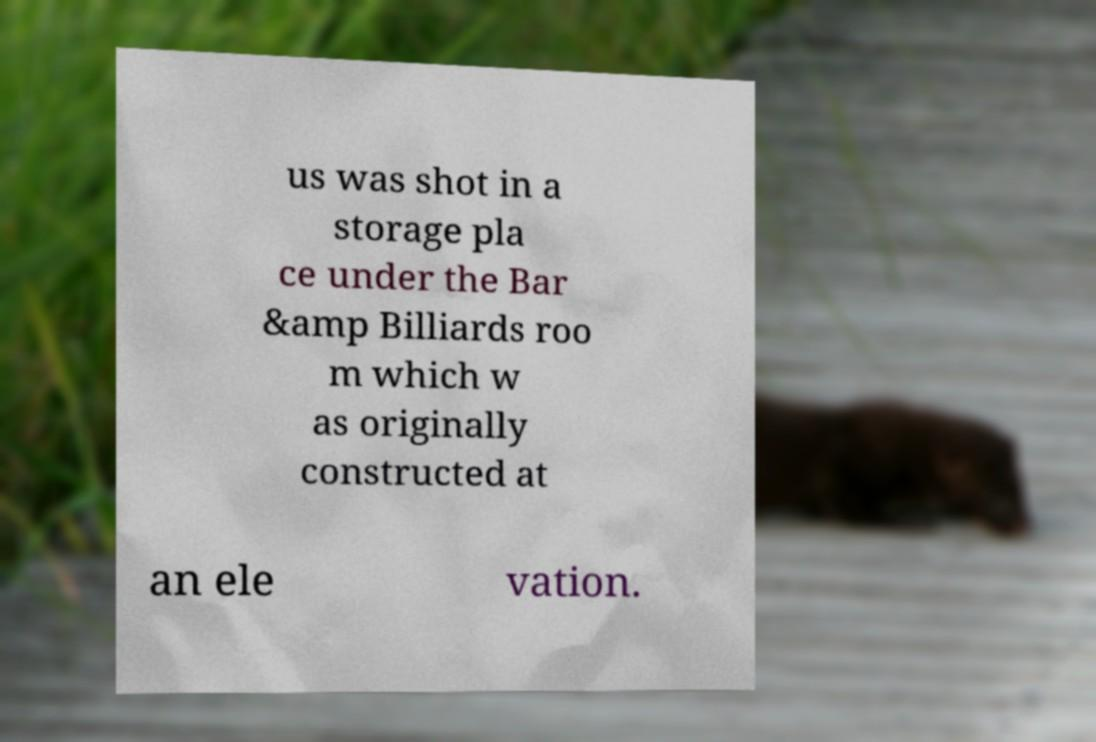Please identify and transcribe the text found in this image. us was shot in a storage pla ce under the Bar &amp Billiards roo m which w as originally constructed at an ele vation. 